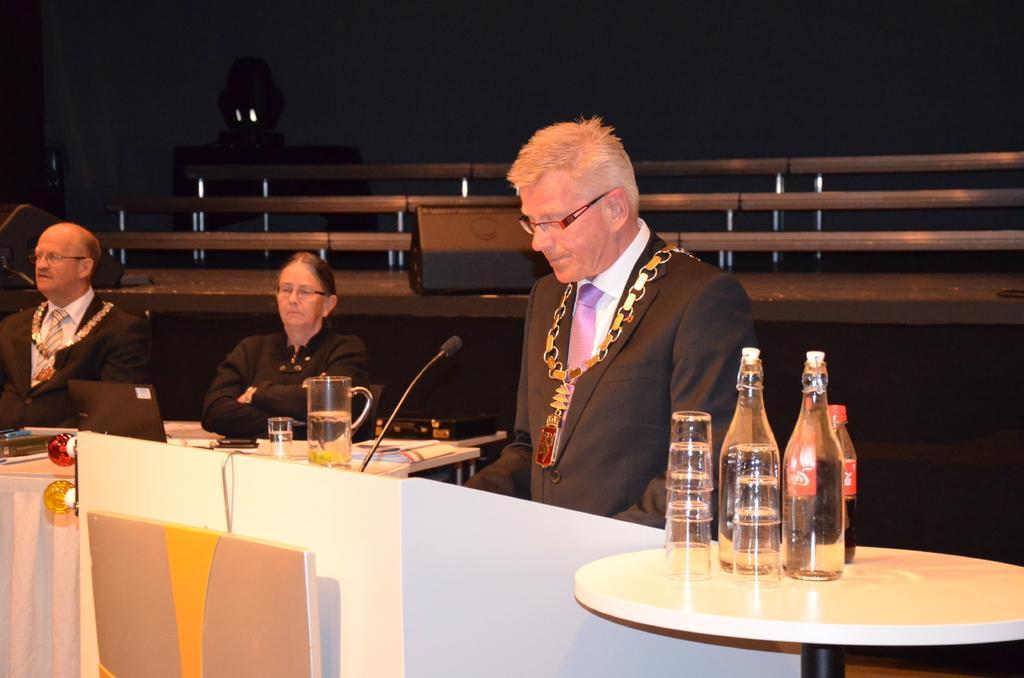Please provide a concise description of this image. In this image we can see three people, among them two are sitting and one is standing in front of the mic, in the center of the image there is a table with some objects and right side there is another table with some bottles and glasses and the background is dark. 